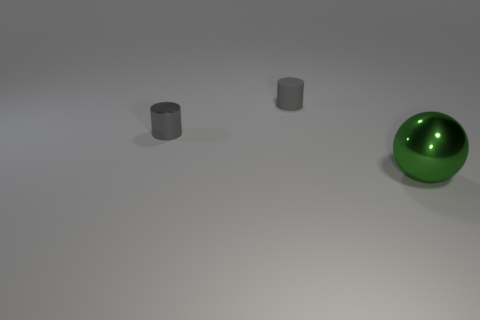There is a metal object to the left of the big green metal object; is its color the same as the big metal sphere?
Give a very brief answer. No. Do the green metal ball and the gray matte object have the same size?
Ensure brevity in your answer.  No. What shape is the metal object that is the same size as the rubber cylinder?
Offer a terse response. Cylinder. Does the metallic object that is left of the green metal sphere have the same size as the metal ball?
Provide a short and direct response. No. What is the material of the other thing that is the same size as the matte object?
Provide a succinct answer. Metal. Are there any large metal things that are left of the small thing that is behind the metallic thing that is behind the green shiny object?
Provide a short and direct response. No. Is there anything else that is the same shape as the green metal object?
Your answer should be compact. No. Does the small cylinder that is to the left of the small gray rubber thing have the same color as the metal thing that is to the right of the gray matte cylinder?
Give a very brief answer. No. Is there a big matte ball?
Make the answer very short. No. What is the material of the thing that is the same color as the shiny cylinder?
Provide a short and direct response. Rubber. 